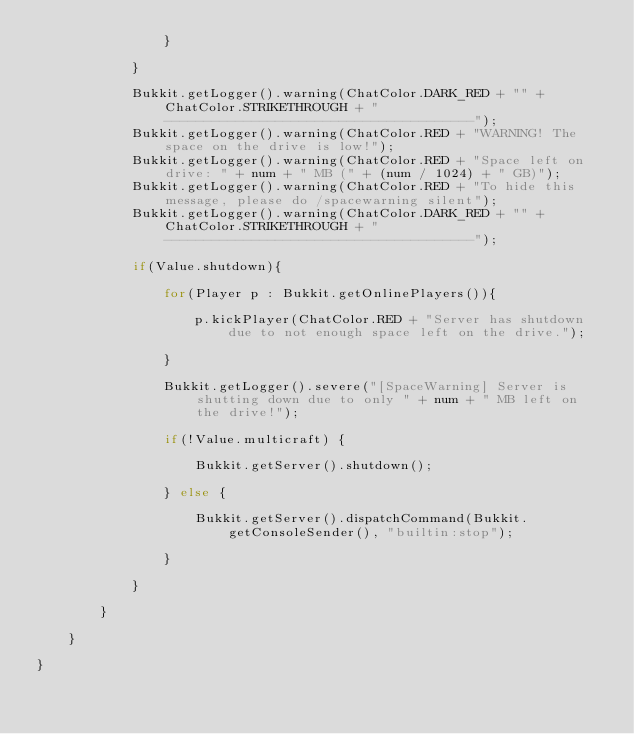Convert code to text. <code><loc_0><loc_0><loc_500><loc_500><_Java_>				}
				
			}
			
			Bukkit.getLogger().warning(ChatColor.DARK_RED + "" + ChatColor.STRIKETHROUGH + "---------------------------------------");
			Bukkit.getLogger().warning(ChatColor.RED + "WARNING! The space on the drive is low!");
			Bukkit.getLogger().warning(ChatColor.RED + "Space left on drive: " + num + " MB (" + (num / 1024) + " GB)");
			Bukkit.getLogger().warning(ChatColor.RED + "To hide this message, please do /spacewarning silent");
			Bukkit.getLogger().warning(ChatColor.DARK_RED + "" + ChatColor.STRIKETHROUGH + "---------------------------------------");
			
			if(Value.shutdown){
				
				for(Player p : Bukkit.getOnlinePlayers()){
					
					p.kickPlayer(ChatColor.RED + "Server has shutdown due to not enough space left on the drive.");
					
				}
				
				Bukkit.getLogger().severe("[SpaceWarning] Server is shutting down due to only " + num + " MB left on the drive!");
				
				if(!Value.multicraft) {
				
					Bukkit.getServer().shutdown();
				
				} else {
					
					Bukkit.getServer().dispatchCommand(Bukkit.getConsoleSender(), "builtin:stop");
					
				}
				
			}
			
		}
		
	}

}
</code> 